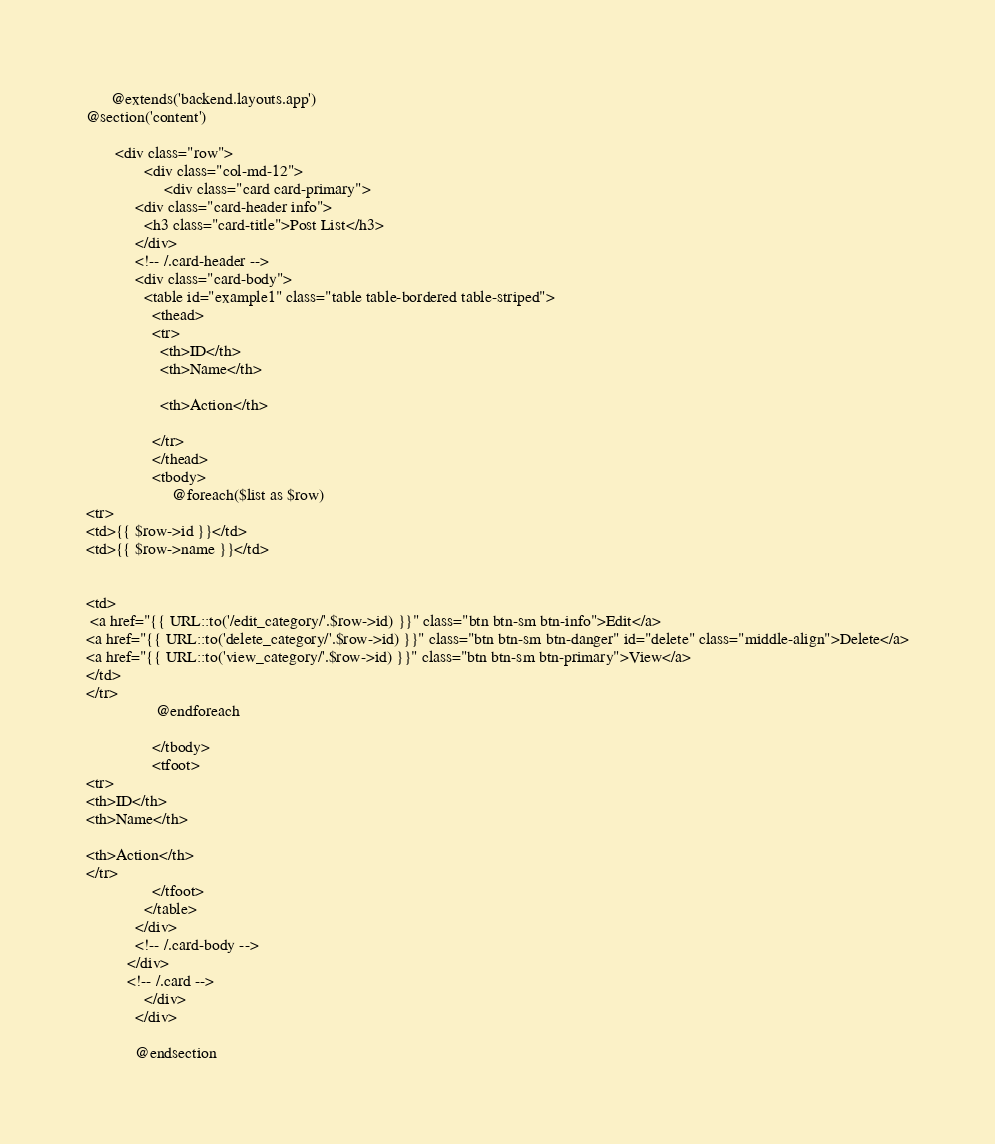Convert code to text. <code><loc_0><loc_0><loc_500><loc_500><_PHP_>      @extends('backend.layouts.app')
@section('content')

       <div class="row">
	          <div class="col-md-12">
	               <div class="card card-primary">
            <div class="card-header info">
              <h3 class="card-title">Post List</h3>
            </div>
            <!-- /.card-header -->
            <div class="card-body">
              <table id="example1" class="table table-bordered table-striped">
                <thead>
                <tr>
                  <th>ID</th>
                  <th>Name</th>
                  
                  <th>Action</th>
                  
                </tr>
                </thead>
                <tbody>
                	 @foreach($list as $row)
<tr>
<td>{{ $row->id }}</td>
<td>{{ $row->name }}</td>


<td>
 <a href="{{ URL::to('/edit_category/'.$row->id) }}" class="btn btn-sm btn-info">Edit</a>
<a href="{{ URL::to('delete_category/'.$row->id) }}" class="btn btn-sm btn-danger" id="delete" class="middle-align">Delete</a>
<a href="{{ URL::to('view_category/'.$row->id) }}" class="btn btn-sm btn-primary">View</a>
</td>
</tr>
                 @endforeach
                
                </tbody>
                <tfoot>
<tr>
<th>ID</th>
<th>Name</th>

<th>Action</th>
</tr>
                </tfoot>
              </table>
            </div>
            <!-- /.card-body -->
          </div>
          <!-- /.card -->
	          </div>
            </div>

            @endsection</code> 